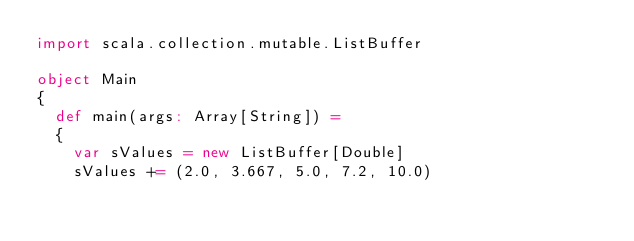Convert code to text. <code><loc_0><loc_0><loc_500><loc_500><_Scala_>import scala.collection.mutable.ListBuffer

object Main
{
  def main(args: Array[String]) =
  {
    var sValues = new ListBuffer[Double]
    sValues += (2.0, 3.667, 5.0, 7.2, 10.0)</code> 